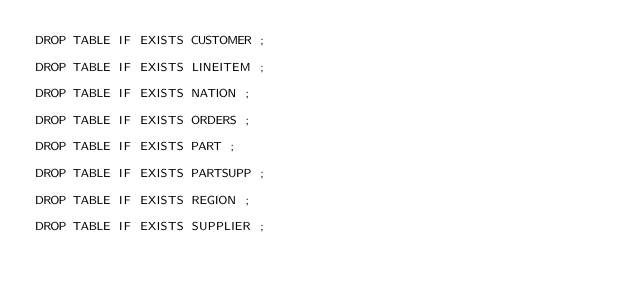Convert code to text. <code><loc_0><loc_0><loc_500><loc_500><_SQL_>DROP TABLE IF EXISTS CUSTOMER ; 

DROP TABLE IF EXISTS LINEITEM ; 

DROP TABLE IF EXISTS NATION ; 

DROP TABLE IF EXISTS ORDERS ; 

DROP TABLE IF EXISTS PART ; 

DROP TABLE IF EXISTS PARTSUPP ; 

DROP TABLE IF EXISTS REGION ; 

DROP TABLE IF EXISTS SUPPLIER ; 

</code> 